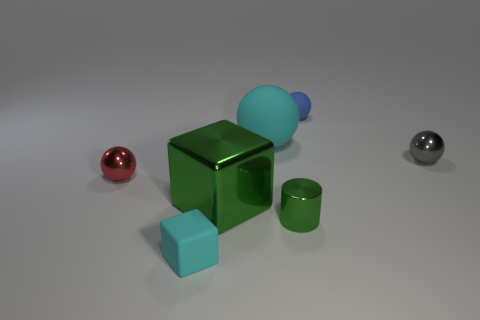Subtract all red balls. How many balls are left? 3 Subtract all cyan balls. How many balls are left? 3 Subtract 1 spheres. How many spheres are left? 3 Subtract all yellow balls. Subtract all yellow blocks. How many balls are left? 4 Add 2 large green shiny blocks. How many objects exist? 9 Subtract all spheres. How many objects are left? 3 Add 6 blue matte balls. How many blue matte balls are left? 7 Add 4 blue spheres. How many blue spheres exist? 5 Subtract 0 brown cylinders. How many objects are left? 7 Subtract all large red cylinders. Subtract all tiny metallic objects. How many objects are left? 4 